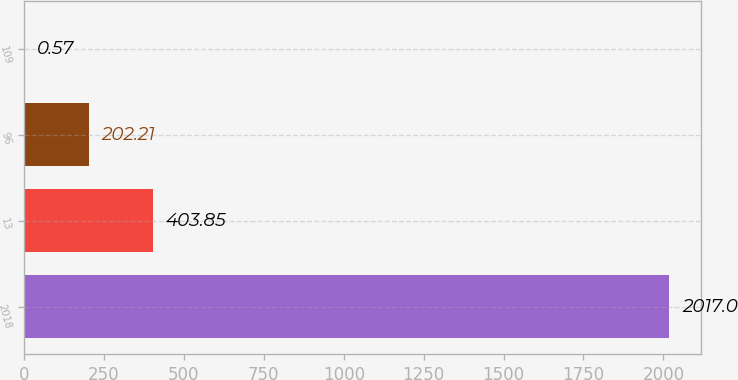Convert chart. <chart><loc_0><loc_0><loc_500><loc_500><bar_chart><fcel>2018<fcel>13<fcel>96<fcel>109<nl><fcel>2017<fcel>403.85<fcel>202.21<fcel>0.57<nl></chart> 